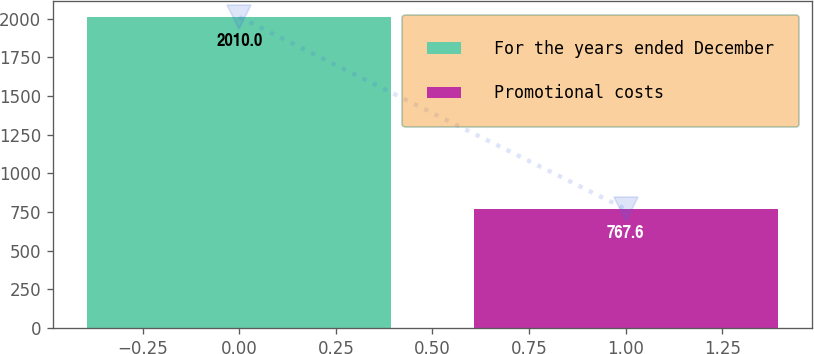Convert chart to OTSL. <chart><loc_0><loc_0><loc_500><loc_500><bar_chart><fcel>For the years ended December<fcel>Promotional costs<nl><fcel>2010<fcel>767.6<nl></chart> 